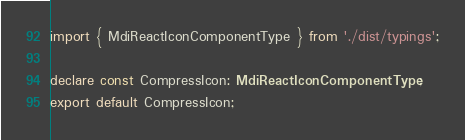<code> <loc_0><loc_0><loc_500><loc_500><_TypeScript_>import { MdiReactIconComponentType } from './dist/typings';

declare const CompressIcon: MdiReactIconComponentType;
export default CompressIcon;
</code> 